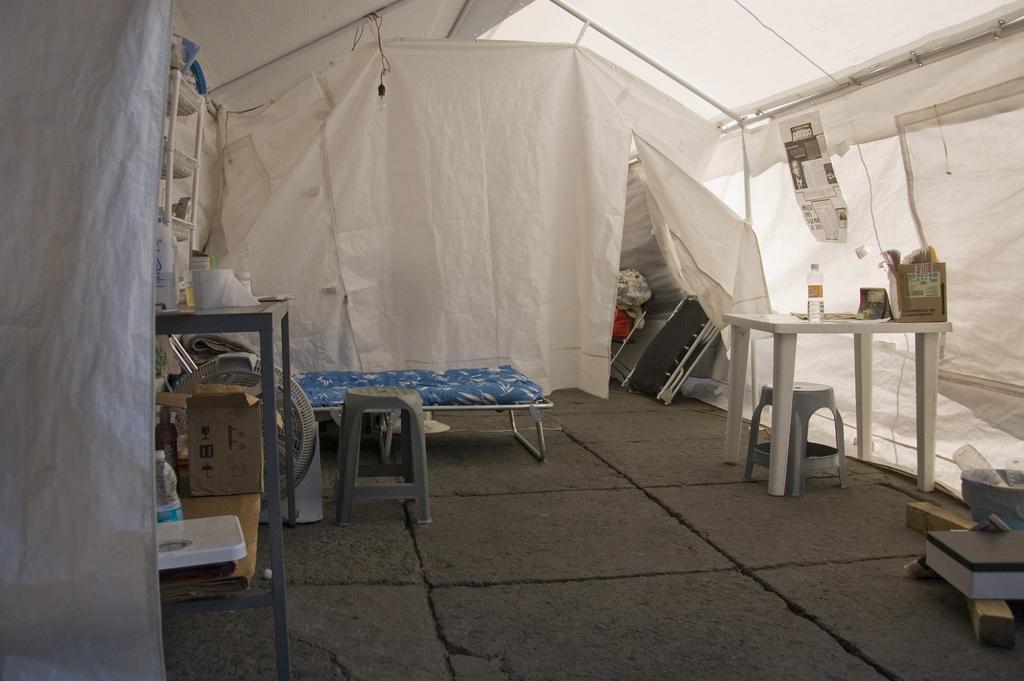How would you summarize this image in a sentence or two? In the image we can see stool, table and on the table, we can see the bottles and carton box. Here we can see the floor, bed and it looks like a tent. 